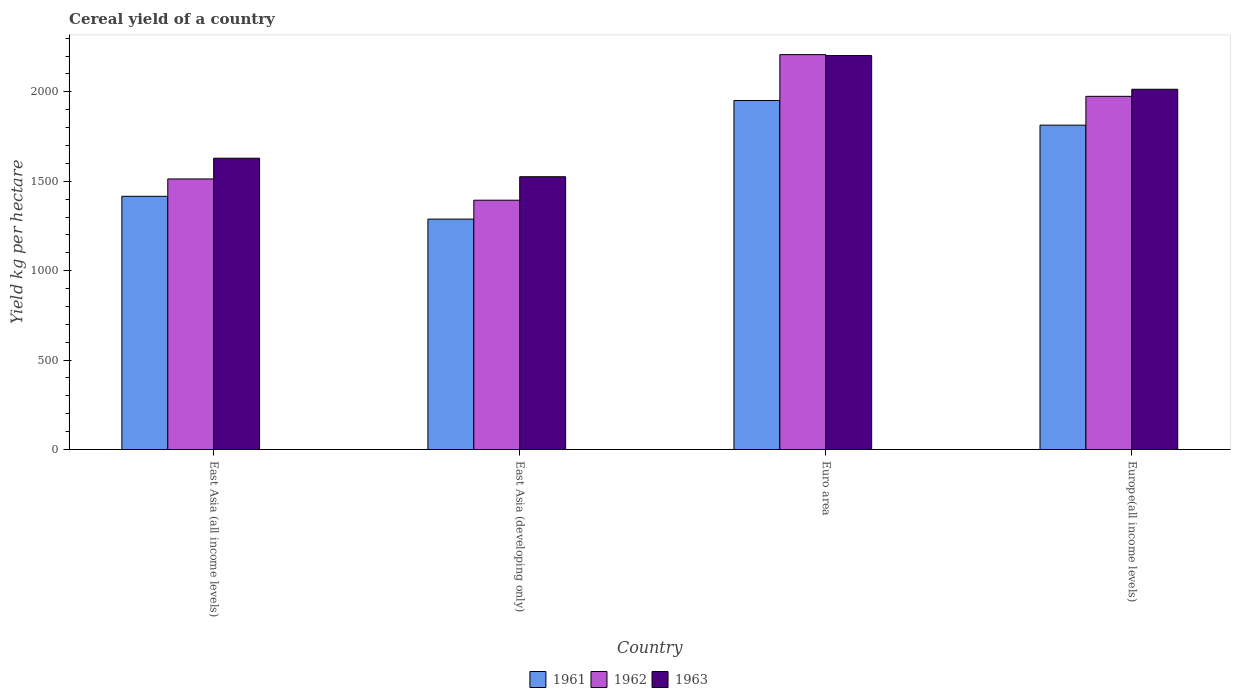How many groups of bars are there?
Ensure brevity in your answer.  4. Are the number of bars per tick equal to the number of legend labels?
Give a very brief answer. Yes. What is the label of the 3rd group of bars from the left?
Your response must be concise. Euro area. What is the total cereal yield in 1961 in Euro area?
Your response must be concise. 1951.5. Across all countries, what is the maximum total cereal yield in 1963?
Offer a terse response. 2202.53. Across all countries, what is the minimum total cereal yield in 1963?
Your answer should be very brief. 1525.26. In which country was the total cereal yield in 1962 maximum?
Ensure brevity in your answer.  Euro area. In which country was the total cereal yield in 1961 minimum?
Provide a succinct answer. East Asia (developing only). What is the total total cereal yield in 1961 in the graph?
Your answer should be very brief. 6469.17. What is the difference between the total cereal yield in 1962 in East Asia (all income levels) and that in East Asia (developing only)?
Keep it short and to the point. 118.93. What is the difference between the total cereal yield in 1962 in East Asia (developing only) and the total cereal yield in 1963 in Euro area?
Make the answer very short. -808.59. What is the average total cereal yield in 1962 per country?
Provide a short and direct response. 1772.38. What is the difference between the total cereal yield of/in 1962 and total cereal yield of/in 1961 in East Asia (all income levels)?
Make the answer very short. 97.06. In how many countries, is the total cereal yield in 1961 greater than 1500 kg per hectare?
Give a very brief answer. 2. What is the ratio of the total cereal yield in 1961 in East Asia (all income levels) to that in Euro area?
Provide a short and direct response. 0.73. Is the total cereal yield in 1962 in Euro area less than that in Europe(all income levels)?
Your response must be concise. No. Is the difference between the total cereal yield in 1962 in Euro area and Europe(all income levels) greater than the difference between the total cereal yield in 1961 in Euro area and Europe(all income levels)?
Your response must be concise. Yes. What is the difference between the highest and the second highest total cereal yield in 1961?
Give a very brief answer. -397.85. What is the difference between the highest and the lowest total cereal yield in 1961?
Make the answer very short. 663.31. In how many countries, is the total cereal yield in 1961 greater than the average total cereal yield in 1961 taken over all countries?
Make the answer very short. 2. Is the sum of the total cereal yield in 1962 in Euro area and Europe(all income levels) greater than the maximum total cereal yield in 1963 across all countries?
Keep it short and to the point. Yes. What does the 2nd bar from the left in East Asia (all income levels) represents?
Your response must be concise. 1962. What does the 2nd bar from the right in Europe(all income levels) represents?
Ensure brevity in your answer.  1962. Are all the bars in the graph horizontal?
Make the answer very short. No. Are the values on the major ticks of Y-axis written in scientific E-notation?
Your response must be concise. No. How many legend labels are there?
Your answer should be compact. 3. How are the legend labels stacked?
Your answer should be compact. Horizontal. What is the title of the graph?
Make the answer very short. Cereal yield of a country. What is the label or title of the X-axis?
Provide a succinct answer. Country. What is the label or title of the Y-axis?
Your answer should be compact. Yield kg per hectare. What is the Yield kg per hectare in 1961 in East Asia (all income levels)?
Give a very brief answer. 1415.81. What is the Yield kg per hectare in 1962 in East Asia (all income levels)?
Your answer should be very brief. 1512.87. What is the Yield kg per hectare in 1963 in East Asia (all income levels)?
Make the answer very short. 1628.8. What is the Yield kg per hectare in 1961 in East Asia (developing only)?
Your answer should be compact. 1288.2. What is the Yield kg per hectare in 1962 in East Asia (developing only)?
Make the answer very short. 1393.94. What is the Yield kg per hectare in 1963 in East Asia (developing only)?
Ensure brevity in your answer.  1525.26. What is the Yield kg per hectare in 1961 in Euro area?
Ensure brevity in your answer.  1951.5. What is the Yield kg per hectare of 1962 in Euro area?
Make the answer very short. 2207.97. What is the Yield kg per hectare of 1963 in Euro area?
Offer a very short reply. 2202.53. What is the Yield kg per hectare in 1961 in Europe(all income levels)?
Your answer should be compact. 1813.66. What is the Yield kg per hectare of 1962 in Europe(all income levels)?
Provide a short and direct response. 1974.73. What is the Yield kg per hectare of 1963 in Europe(all income levels)?
Your response must be concise. 2014.33. Across all countries, what is the maximum Yield kg per hectare of 1961?
Offer a very short reply. 1951.5. Across all countries, what is the maximum Yield kg per hectare of 1962?
Offer a terse response. 2207.97. Across all countries, what is the maximum Yield kg per hectare of 1963?
Keep it short and to the point. 2202.53. Across all countries, what is the minimum Yield kg per hectare of 1961?
Make the answer very short. 1288.2. Across all countries, what is the minimum Yield kg per hectare in 1962?
Your answer should be compact. 1393.94. Across all countries, what is the minimum Yield kg per hectare of 1963?
Keep it short and to the point. 1525.26. What is the total Yield kg per hectare of 1961 in the graph?
Your response must be concise. 6469.17. What is the total Yield kg per hectare of 1962 in the graph?
Your answer should be very brief. 7089.51. What is the total Yield kg per hectare in 1963 in the graph?
Your answer should be very brief. 7370.91. What is the difference between the Yield kg per hectare of 1961 in East Asia (all income levels) and that in East Asia (developing only)?
Keep it short and to the point. 127.62. What is the difference between the Yield kg per hectare of 1962 in East Asia (all income levels) and that in East Asia (developing only)?
Offer a very short reply. 118.93. What is the difference between the Yield kg per hectare of 1963 in East Asia (all income levels) and that in East Asia (developing only)?
Make the answer very short. 103.54. What is the difference between the Yield kg per hectare in 1961 in East Asia (all income levels) and that in Euro area?
Your answer should be very brief. -535.69. What is the difference between the Yield kg per hectare in 1962 in East Asia (all income levels) and that in Euro area?
Keep it short and to the point. -695.09. What is the difference between the Yield kg per hectare of 1963 in East Asia (all income levels) and that in Euro area?
Keep it short and to the point. -573.73. What is the difference between the Yield kg per hectare in 1961 in East Asia (all income levels) and that in Europe(all income levels)?
Your answer should be compact. -397.85. What is the difference between the Yield kg per hectare of 1962 in East Asia (all income levels) and that in Europe(all income levels)?
Make the answer very short. -461.86. What is the difference between the Yield kg per hectare of 1963 in East Asia (all income levels) and that in Europe(all income levels)?
Your response must be concise. -385.53. What is the difference between the Yield kg per hectare in 1961 in East Asia (developing only) and that in Euro area?
Make the answer very short. -663.31. What is the difference between the Yield kg per hectare in 1962 in East Asia (developing only) and that in Euro area?
Ensure brevity in your answer.  -814.03. What is the difference between the Yield kg per hectare in 1963 in East Asia (developing only) and that in Euro area?
Provide a succinct answer. -677.27. What is the difference between the Yield kg per hectare of 1961 in East Asia (developing only) and that in Europe(all income levels)?
Provide a short and direct response. -525.46. What is the difference between the Yield kg per hectare in 1962 in East Asia (developing only) and that in Europe(all income levels)?
Keep it short and to the point. -580.8. What is the difference between the Yield kg per hectare of 1963 in East Asia (developing only) and that in Europe(all income levels)?
Provide a succinct answer. -489.08. What is the difference between the Yield kg per hectare of 1961 in Euro area and that in Europe(all income levels)?
Make the answer very short. 137.84. What is the difference between the Yield kg per hectare of 1962 in Euro area and that in Europe(all income levels)?
Keep it short and to the point. 233.23. What is the difference between the Yield kg per hectare of 1963 in Euro area and that in Europe(all income levels)?
Provide a short and direct response. 188.19. What is the difference between the Yield kg per hectare of 1961 in East Asia (all income levels) and the Yield kg per hectare of 1962 in East Asia (developing only)?
Provide a short and direct response. 21.88. What is the difference between the Yield kg per hectare in 1961 in East Asia (all income levels) and the Yield kg per hectare in 1963 in East Asia (developing only)?
Your response must be concise. -109.44. What is the difference between the Yield kg per hectare in 1962 in East Asia (all income levels) and the Yield kg per hectare in 1963 in East Asia (developing only)?
Your response must be concise. -12.38. What is the difference between the Yield kg per hectare of 1961 in East Asia (all income levels) and the Yield kg per hectare of 1962 in Euro area?
Offer a terse response. -792.15. What is the difference between the Yield kg per hectare in 1961 in East Asia (all income levels) and the Yield kg per hectare in 1963 in Euro area?
Provide a short and direct response. -786.71. What is the difference between the Yield kg per hectare in 1962 in East Asia (all income levels) and the Yield kg per hectare in 1963 in Euro area?
Make the answer very short. -689.65. What is the difference between the Yield kg per hectare in 1961 in East Asia (all income levels) and the Yield kg per hectare in 1962 in Europe(all income levels)?
Ensure brevity in your answer.  -558.92. What is the difference between the Yield kg per hectare of 1961 in East Asia (all income levels) and the Yield kg per hectare of 1963 in Europe(all income levels)?
Ensure brevity in your answer.  -598.52. What is the difference between the Yield kg per hectare of 1962 in East Asia (all income levels) and the Yield kg per hectare of 1963 in Europe(all income levels)?
Ensure brevity in your answer.  -501.46. What is the difference between the Yield kg per hectare in 1961 in East Asia (developing only) and the Yield kg per hectare in 1962 in Euro area?
Your response must be concise. -919.77. What is the difference between the Yield kg per hectare of 1961 in East Asia (developing only) and the Yield kg per hectare of 1963 in Euro area?
Make the answer very short. -914.33. What is the difference between the Yield kg per hectare in 1962 in East Asia (developing only) and the Yield kg per hectare in 1963 in Euro area?
Give a very brief answer. -808.59. What is the difference between the Yield kg per hectare in 1961 in East Asia (developing only) and the Yield kg per hectare in 1962 in Europe(all income levels)?
Offer a terse response. -686.54. What is the difference between the Yield kg per hectare of 1961 in East Asia (developing only) and the Yield kg per hectare of 1963 in Europe(all income levels)?
Your answer should be very brief. -726.14. What is the difference between the Yield kg per hectare in 1962 in East Asia (developing only) and the Yield kg per hectare in 1963 in Europe(all income levels)?
Keep it short and to the point. -620.4. What is the difference between the Yield kg per hectare of 1961 in Euro area and the Yield kg per hectare of 1962 in Europe(all income levels)?
Provide a succinct answer. -23.23. What is the difference between the Yield kg per hectare of 1961 in Euro area and the Yield kg per hectare of 1963 in Europe(all income levels)?
Offer a very short reply. -62.83. What is the difference between the Yield kg per hectare in 1962 in Euro area and the Yield kg per hectare in 1963 in Europe(all income levels)?
Provide a succinct answer. 193.63. What is the average Yield kg per hectare in 1961 per country?
Offer a very short reply. 1617.29. What is the average Yield kg per hectare of 1962 per country?
Provide a succinct answer. 1772.38. What is the average Yield kg per hectare of 1963 per country?
Make the answer very short. 1842.73. What is the difference between the Yield kg per hectare in 1961 and Yield kg per hectare in 1962 in East Asia (all income levels)?
Make the answer very short. -97.06. What is the difference between the Yield kg per hectare in 1961 and Yield kg per hectare in 1963 in East Asia (all income levels)?
Provide a succinct answer. -212.99. What is the difference between the Yield kg per hectare of 1962 and Yield kg per hectare of 1963 in East Asia (all income levels)?
Provide a short and direct response. -115.93. What is the difference between the Yield kg per hectare of 1961 and Yield kg per hectare of 1962 in East Asia (developing only)?
Your answer should be compact. -105.74. What is the difference between the Yield kg per hectare in 1961 and Yield kg per hectare in 1963 in East Asia (developing only)?
Offer a terse response. -237.06. What is the difference between the Yield kg per hectare in 1962 and Yield kg per hectare in 1963 in East Asia (developing only)?
Provide a short and direct response. -131.32. What is the difference between the Yield kg per hectare in 1961 and Yield kg per hectare in 1962 in Euro area?
Offer a very short reply. -256.46. What is the difference between the Yield kg per hectare in 1961 and Yield kg per hectare in 1963 in Euro area?
Make the answer very short. -251.02. What is the difference between the Yield kg per hectare of 1962 and Yield kg per hectare of 1963 in Euro area?
Your answer should be compact. 5.44. What is the difference between the Yield kg per hectare of 1961 and Yield kg per hectare of 1962 in Europe(all income levels)?
Make the answer very short. -161.07. What is the difference between the Yield kg per hectare in 1961 and Yield kg per hectare in 1963 in Europe(all income levels)?
Your answer should be compact. -200.67. What is the difference between the Yield kg per hectare of 1962 and Yield kg per hectare of 1963 in Europe(all income levels)?
Your answer should be compact. -39.6. What is the ratio of the Yield kg per hectare in 1961 in East Asia (all income levels) to that in East Asia (developing only)?
Your answer should be very brief. 1.1. What is the ratio of the Yield kg per hectare of 1962 in East Asia (all income levels) to that in East Asia (developing only)?
Give a very brief answer. 1.09. What is the ratio of the Yield kg per hectare in 1963 in East Asia (all income levels) to that in East Asia (developing only)?
Offer a terse response. 1.07. What is the ratio of the Yield kg per hectare in 1961 in East Asia (all income levels) to that in Euro area?
Keep it short and to the point. 0.73. What is the ratio of the Yield kg per hectare of 1962 in East Asia (all income levels) to that in Euro area?
Offer a terse response. 0.69. What is the ratio of the Yield kg per hectare of 1963 in East Asia (all income levels) to that in Euro area?
Your answer should be compact. 0.74. What is the ratio of the Yield kg per hectare of 1961 in East Asia (all income levels) to that in Europe(all income levels)?
Offer a very short reply. 0.78. What is the ratio of the Yield kg per hectare of 1962 in East Asia (all income levels) to that in Europe(all income levels)?
Provide a short and direct response. 0.77. What is the ratio of the Yield kg per hectare in 1963 in East Asia (all income levels) to that in Europe(all income levels)?
Your answer should be very brief. 0.81. What is the ratio of the Yield kg per hectare of 1961 in East Asia (developing only) to that in Euro area?
Provide a short and direct response. 0.66. What is the ratio of the Yield kg per hectare in 1962 in East Asia (developing only) to that in Euro area?
Keep it short and to the point. 0.63. What is the ratio of the Yield kg per hectare of 1963 in East Asia (developing only) to that in Euro area?
Offer a very short reply. 0.69. What is the ratio of the Yield kg per hectare in 1961 in East Asia (developing only) to that in Europe(all income levels)?
Keep it short and to the point. 0.71. What is the ratio of the Yield kg per hectare of 1962 in East Asia (developing only) to that in Europe(all income levels)?
Your answer should be very brief. 0.71. What is the ratio of the Yield kg per hectare of 1963 in East Asia (developing only) to that in Europe(all income levels)?
Offer a very short reply. 0.76. What is the ratio of the Yield kg per hectare in 1961 in Euro area to that in Europe(all income levels)?
Make the answer very short. 1.08. What is the ratio of the Yield kg per hectare in 1962 in Euro area to that in Europe(all income levels)?
Provide a succinct answer. 1.12. What is the ratio of the Yield kg per hectare in 1963 in Euro area to that in Europe(all income levels)?
Your answer should be very brief. 1.09. What is the difference between the highest and the second highest Yield kg per hectare in 1961?
Provide a short and direct response. 137.84. What is the difference between the highest and the second highest Yield kg per hectare of 1962?
Your answer should be compact. 233.23. What is the difference between the highest and the second highest Yield kg per hectare of 1963?
Give a very brief answer. 188.19. What is the difference between the highest and the lowest Yield kg per hectare in 1961?
Keep it short and to the point. 663.31. What is the difference between the highest and the lowest Yield kg per hectare of 1962?
Keep it short and to the point. 814.03. What is the difference between the highest and the lowest Yield kg per hectare of 1963?
Provide a short and direct response. 677.27. 